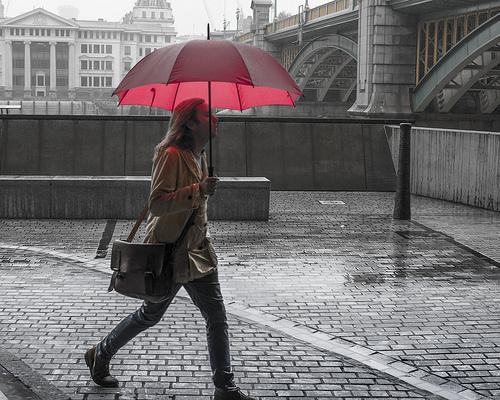Question: what type of surface is the person walking on?
Choices:
A. Cement.
B. Brick.
C. Pavement.
D. Sand.
Answer with the letter. Answer: B Question: what is in the left background?
Choices:
A. Animals.
B. Pets.
C. A building.
D. Trees.
Answer with the letter. Answer: C Question: what direction is the person going?
Choices:
A. To the right.
B. To the left.
C. To the front.
D. To the back.
Answer with the letter. Answer: A Question: why are the bricks shiny?
Choices:
A. Painted.
B. Gloss.
C. Rain.
D. They are wet.
Answer with the letter. Answer: D Question: where is the person's umbrella?
Choices:
A. Above their head.
B. In the right hand.
C. Left hand.
D. In car.
Answer with the letter. Answer: B Question: what color is the umbrella?
Choices:
A. Yellow.
B. Blue.
C. Green.
D. Red.
Answer with the letter. Answer: D Question: what is to the left of the person?
Choices:
A. Another person.
B. Dog.
C. A stone bench.
D. Car.
Answer with the letter. Answer: C 